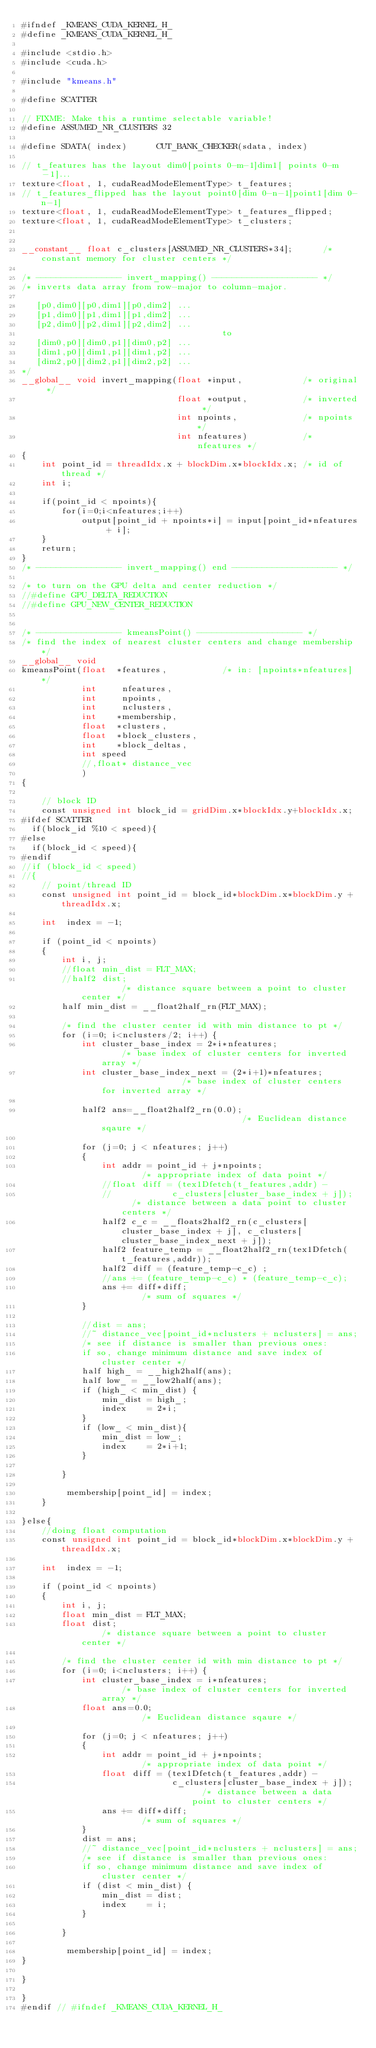Convert code to text. <code><loc_0><loc_0><loc_500><loc_500><_Cuda_>#ifndef _KMEANS_CUDA_KERNEL_H_
#define _KMEANS_CUDA_KERNEL_H_

#include <stdio.h>
#include <cuda.h>

#include "kmeans.h"

#define SCATTER

// FIXME: Make this a runtime selectable variable!
#define ASSUMED_NR_CLUSTERS 32

#define SDATA( index)      CUT_BANK_CHECKER(sdata, index)

// t_features has the layout dim0[points 0-m-1]dim1[ points 0-m-1]...
texture<float, 1, cudaReadModeElementType> t_features;
// t_features_flipped has the layout point0[dim 0-n-1]point1[dim 0-n-1]
texture<float, 1, cudaReadModeElementType> t_features_flipped;
texture<float, 1, cudaReadModeElementType> t_clusters;


__constant__ float c_clusters[ASSUMED_NR_CLUSTERS*34];		/* constant memory for cluster centers */

/* ----------------- invert_mapping() --------------------- */
/* inverts data array from row-major to column-major.

   [p0,dim0][p0,dim1][p0,dim2] ...
   [p1,dim0][p1,dim1][p1,dim2] ...
   [p2,dim0][p2,dim1][p2,dim2] ...
										to
   [dim0,p0][dim0,p1][dim0,p2] ...
   [dim1,p0][dim1,p1][dim1,p2] ...
   [dim2,p0][dim2,p1][dim2,p2] ...
*/
__global__ void invert_mapping(float *input,			/* original */
							   float *output,			/* inverted */
							   int npoints,				/* npoints */
							   int nfeatures)			/* nfeatures */
{
	int point_id = threadIdx.x + blockDim.x*blockIdx.x;	/* id of thread */
	int i;

	if(point_id < npoints){
		for(i=0;i<nfeatures;i++)
			output[point_id + npoints*i] = input[point_id*nfeatures + i];
	}
	return;
}
/* ----------------- invert_mapping() end --------------------- */

/* to turn on the GPU delta and center reduction */
//#define GPU_DELTA_REDUCTION
//#define GPU_NEW_CENTER_REDUCTION


/* ----------------- kmeansPoint() --------------------- */
/* find the index of nearest cluster centers and change membership*/
__global__ void
kmeansPoint(float  *features,			/* in: [npoints*nfeatures] */
            int     nfeatures,
            int     npoints,
            int     nclusters,
            int    *membership,
			float  *clusters,
			float  *block_clusters,
			int    *block_deltas,
			int speed
			//,float* distance_vec
			)
{

	// block ID
	const unsigned int block_id = gridDim.x*blockIdx.y+blockIdx.x;
#ifdef SCATTER
  if(block_id %10 < speed){
#else
  if(block_id < speed){
#endif
//if (block_id < speed)
//{
	// point/thread ID
	const unsigned int point_id = block_id*blockDim.x*blockDim.y + threadIdx.x;

	int  index = -1;

	if (point_id < npoints)
	{
		int i, j;
		//float min_dist = FLT_MAX;
		//half2 dist;													/* distance square between a point to cluster center */
		half min_dist = __float2half_rn(FLT_MAX);

		/* find the cluster center id with min distance to pt */
		for (i=0; i<nclusters/2; i++) {
			int cluster_base_index = 2*i*nfeatures;					/* base index of cluster centers for inverted array */
			int cluster_base_index_next = (2*i+1)*nfeatures;					/* base index of cluster centers for inverted array */

			half2 ans=__float2half2_rn(0.0);												/* Euclidean distance sqaure */

			for (j=0; j < nfeatures; j++)
			{
				int addr = point_id + j*npoints;					/* appropriate index of data point */
				//float diff = (tex1Dfetch(t_features,addr) -
				//			  c_clusters[cluster_base_index + j]);	/* distance between a data point to cluster centers */
				half2 c_c = __floats2half2_rn(c_clusters[cluster_base_index + j], c_clusters[cluster_base_index_next + j]);
				half2 feature_temp = __float2half2_rn(tex1Dfetch(t_features,addr));
				half2 diff = (feature_temp-c_c) ;
				//ans += (feature_temp-c_c) * (feature_temp-c_c);
				ans += diff*diff;									/* sum of squares */
			}

			//dist = ans;
			//~ distance_vec[point_id*nclusters + nclusters] = ans;
			/* see if distance is smaller than previous ones:
			if so, change minimum distance and save index of cluster center */
			half high_ = __high2half(ans);
			half low_ = __low2half(ans);
			if (high_ < min_dist) {
				min_dist = high_;
				index    = 2*i;
			}
			if (low_ < min_dist){
				min_dist = low_;
				index    = 2*i+1;
			}

		}

		 membership[point_id] = index;
	}

}else{
	//doing float computation
	const unsigned int point_id = block_id*blockDim.x*blockDim.y + threadIdx.x;

	int  index = -1;

	if (point_id < npoints)
	{
		int i, j;
		float min_dist = FLT_MAX;
		float dist;													/* distance square between a point to cluster center */

		/* find the cluster center id with min distance to pt */
		for (i=0; i<nclusters; i++) {
			int cluster_base_index = i*nfeatures;					/* base index of cluster centers for inverted array */
			float ans=0.0;												/* Euclidean distance sqaure */

			for (j=0; j < nfeatures; j++)
			{
				int addr = point_id + j*npoints;					/* appropriate index of data point */
				float diff = (tex1Dfetch(t_features,addr) -
							  c_clusters[cluster_base_index + j]);	/* distance between a data point to cluster centers */
				ans += diff*diff;									/* sum of squares */
			}
			dist = ans;
			//~ distance_vec[point_id*nclusters + nclusters] = ans;
			/* see if distance is smaller than previous ones:
			if so, change minimum distance and save index of cluster center */
			if (dist < min_dist) {
				min_dist = dist;
				index    = i;
			}

		}

		 membership[point_id] = index;
}

}

}
#endif // #ifndef _KMEANS_CUDA_KERNEL_H_
</code> 